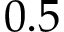Convert formula to latex. <formula><loc_0><loc_0><loc_500><loc_500>0 . 5</formula> 